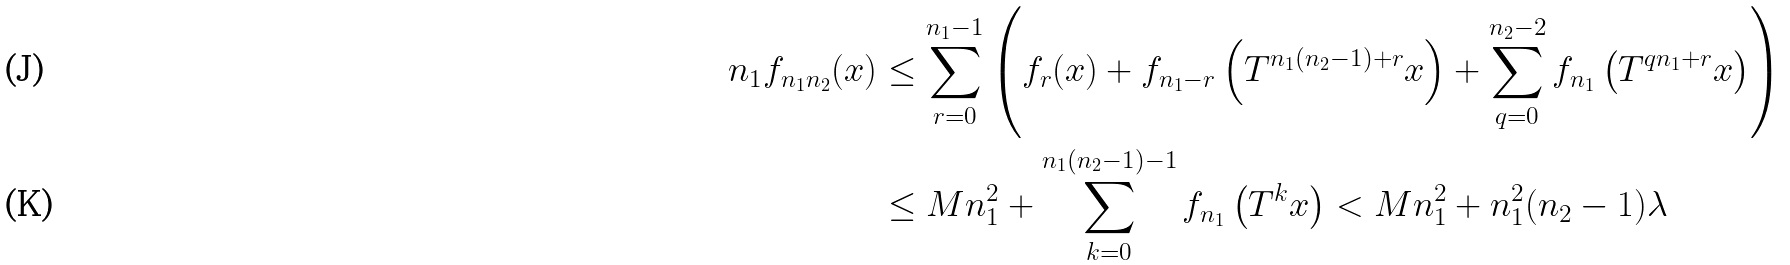<formula> <loc_0><loc_0><loc_500><loc_500>n _ { 1 } f _ { n _ { 1 } n _ { 2 } } ( x ) & \leq \sum _ { r = 0 } ^ { n _ { 1 } - 1 } \left ( f _ { r } ( x ) + f _ { n _ { 1 } - r } \left ( T ^ { n _ { 1 } ( n _ { 2 } - 1 ) + r } x \right ) + \sum _ { q = 0 } ^ { n _ { 2 } - 2 } f _ { n _ { 1 } } \left ( T ^ { q n _ { 1 } + r } x \right ) \right ) \\ & \leq M n _ { 1 } ^ { 2 } + \sum _ { k = 0 } ^ { n _ { 1 } ( n _ { 2 } - 1 ) - 1 } f _ { n _ { 1 } } \left ( T ^ { k } x \right ) < M n _ { 1 } ^ { 2 } + n _ { 1 } ^ { 2 } ( n _ { 2 } - 1 ) \lambda</formula> 